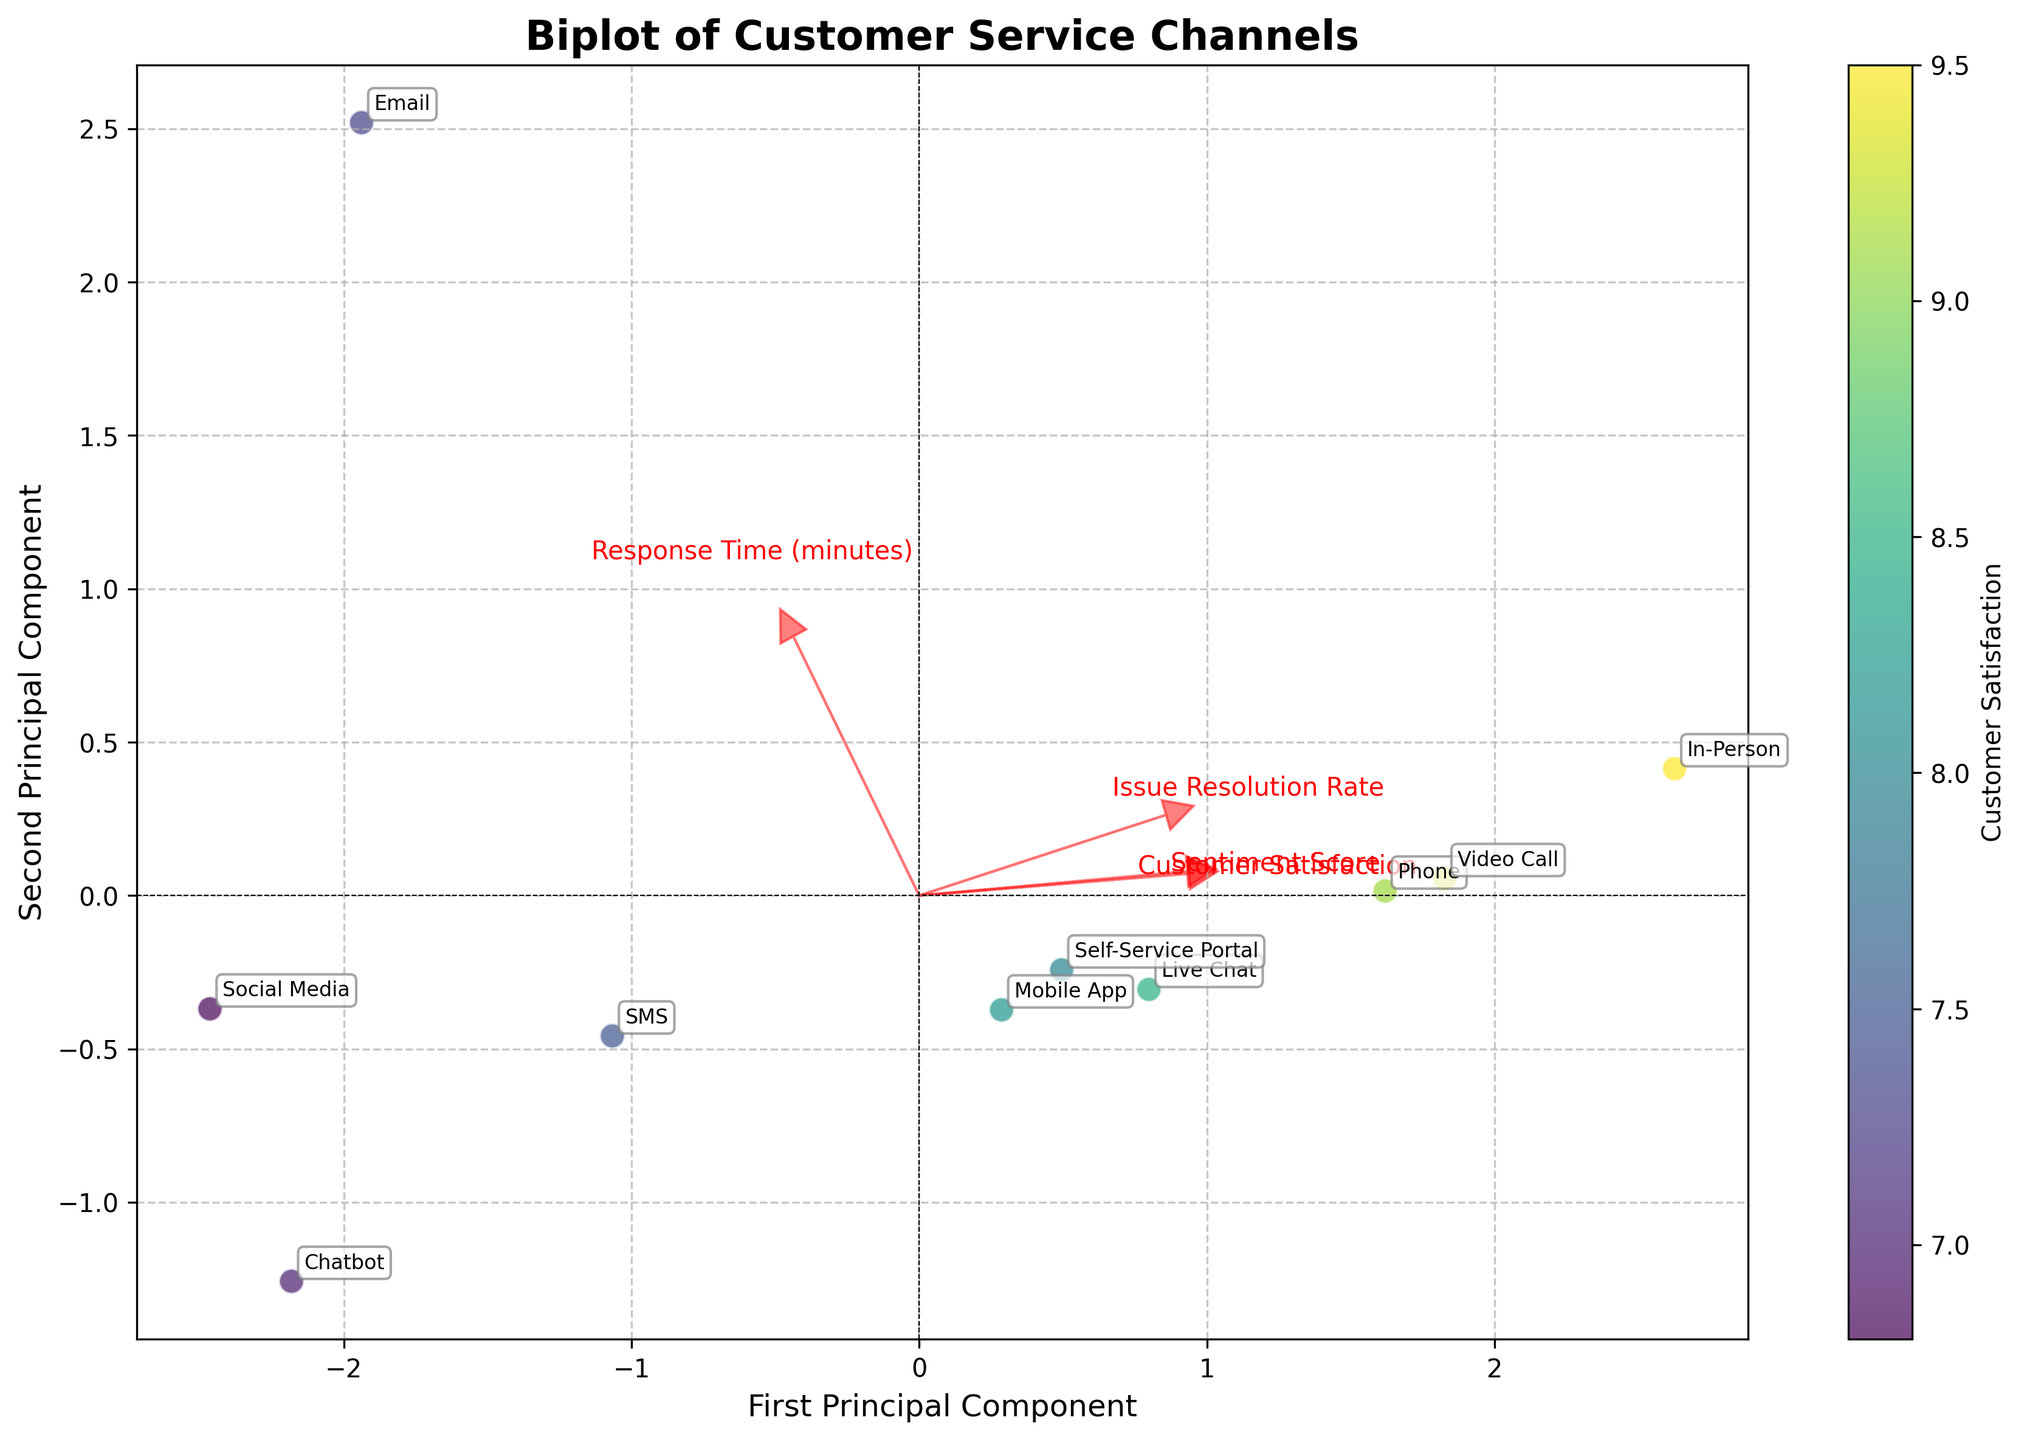How many customer service channels are represented in the biplot? There are labels for each channel on the biplot, marking their positions on the plot. Counting the number of unique labels gives the total number of customer service channels.
Answer: 10 What does the color of the data points represent in the biplot? The color of the data points corresponds to the 'Customer Satisfaction' score, with varying shades indicating different levels.
Answer: Customer Satisfaction Which customer service channel has the highest Customer Satisfaction score according to its color? On the biplot, the color intensity indicates the Customer Satisfaction score. The 'In-Person' channel has the brightest color, indicating the highest score.
Answer: In-Person Which feature vector points in the direction of reducing response time? In the biplot, the 'Response Time (minutes)' vector points in a specific direction. The feature vector pointing towards lower values on its axis indicates reducing response time.
Answer: Bottom-right Compare the positions of 'Email' and 'Live Chat' based on the first principal component. Which one has a higher value? On the biplot, the first principal component is represented on the X-axis. By comparing the X-coordinates of 'Email' and 'Live Chat', we can determine which has a higher value.
Answer: Live Chat Which feature has the longest eigenvector in the biplot, indicating the highest variance? The length of the eigenvectors in the biplot corresponds to the variance explained by each feature. The longest eigenvector indicates the feature with the highest variance.
Answer: Sentiment Score How does 'Phone' compare to 'Social Media' in terms of the second principal component? In the biplot, the second principal component is represented on the Y-axis. By comparing the Y-coordinates of 'Phone' and 'Social Media', we determine their relative positions.
Answer: Phone is higher Identify the two channels that are closest to each other in the biplot. By visually examining the distances between the points, we can determine which two channels are closest to each other in the biplot.
Answer: Mobile App and Live Chat Which channels are associated with high 'Issue Resolution Rate'? In the biplot, the 'Issue Resolution Rate' vector points in a direction. Channels positioned along this vector's positive direction indicate high 'Issue Resolution Rate'.
Answer: Self-Service Portal and In-Person What trend can be observed between 'Customer Satisfaction' and 'Sentiment Score' based on their eigenvectors? The eigenvectors' directions indicate the relationship between features. If 'Customer Satisfaction' and 'Sentiment Score' eigenvectors are closely aligned, it shows a direct correlation.
Answer: Positive correlation 